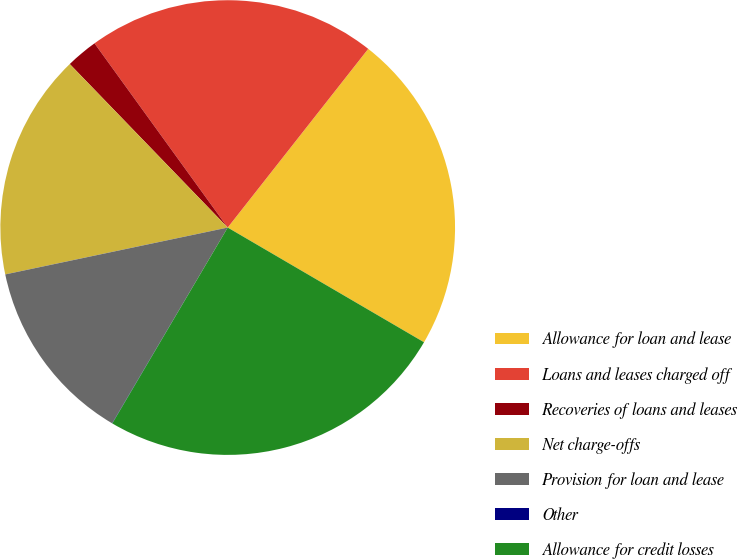Convert chart. <chart><loc_0><loc_0><loc_500><loc_500><pie_chart><fcel>Allowance for loan and lease<fcel>Loans and leases charged off<fcel>Recoveries of loans and leases<fcel>Net charge-offs<fcel>Provision for loan and lease<fcel>Other<fcel>Allowance for credit losses<nl><fcel>22.81%<fcel>20.57%<fcel>2.26%<fcel>16.08%<fcel>13.2%<fcel>0.02%<fcel>25.06%<nl></chart> 